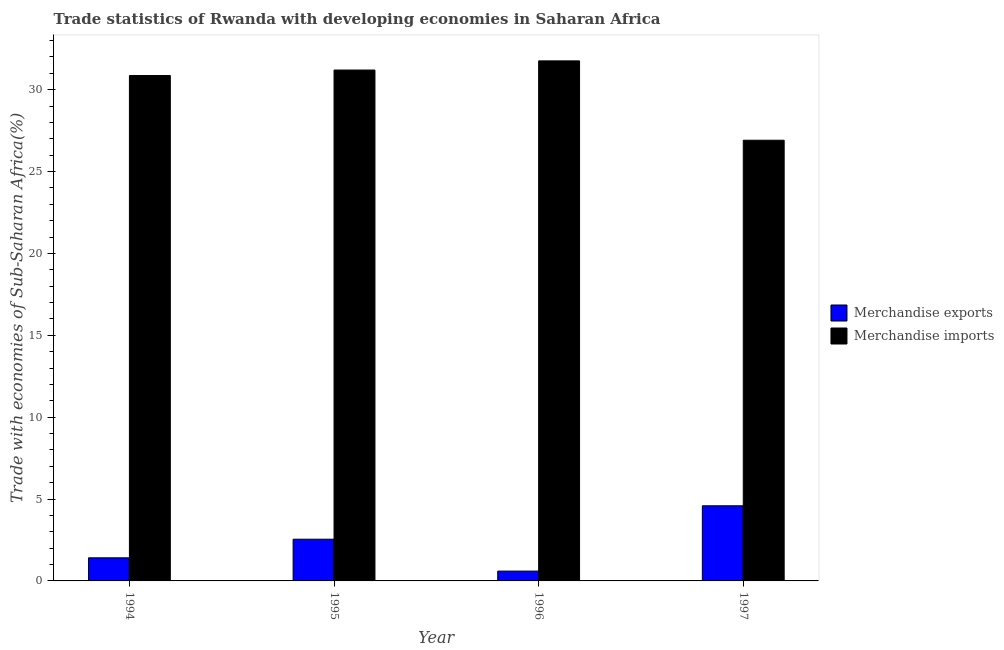How many bars are there on the 4th tick from the right?
Give a very brief answer. 2. What is the merchandise exports in 1997?
Your answer should be compact. 4.59. Across all years, what is the maximum merchandise imports?
Your response must be concise. 31.76. Across all years, what is the minimum merchandise imports?
Provide a succinct answer. 26.91. In which year was the merchandise exports maximum?
Offer a very short reply. 1997. In which year was the merchandise imports minimum?
Provide a short and direct response. 1997. What is the total merchandise exports in the graph?
Keep it short and to the point. 9.15. What is the difference between the merchandise imports in 1994 and that in 1995?
Offer a very short reply. -0.33. What is the difference between the merchandise imports in 1996 and the merchandise exports in 1997?
Keep it short and to the point. 4.85. What is the average merchandise exports per year?
Offer a terse response. 2.29. What is the ratio of the merchandise exports in 1994 to that in 1995?
Provide a short and direct response. 0.55. Is the difference between the merchandise imports in 1996 and 1997 greater than the difference between the merchandise exports in 1996 and 1997?
Make the answer very short. No. What is the difference between the highest and the second highest merchandise exports?
Your answer should be compact. 2.04. What is the difference between the highest and the lowest merchandise exports?
Offer a very short reply. 3.99. In how many years, is the merchandise exports greater than the average merchandise exports taken over all years?
Your response must be concise. 2. How many bars are there?
Keep it short and to the point. 8. Are all the bars in the graph horizontal?
Ensure brevity in your answer.  No. How many years are there in the graph?
Give a very brief answer. 4. What is the difference between two consecutive major ticks on the Y-axis?
Give a very brief answer. 5. Does the graph contain grids?
Provide a short and direct response. No. What is the title of the graph?
Provide a succinct answer. Trade statistics of Rwanda with developing economies in Saharan Africa. Does "Banks" appear as one of the legend labels in the graph?
Give a very brief answer. No. What is the label or title of the Y-axis?
Offer a very short reply. Trade with economies of Sub-Saharan Africa(%). What is the Trade with economies of Sub-Saharan Africa(%) in Merchandise exports in 1994?
Your answer should be very brief. 1.41. What is the Trade with economies of Sub-Saharan Africa(%) of Merchandise imports in 1994?
Ensure brevity in your answer.  30.86. What is the Trade with economies of Sub-Saharan Africa(%) in Merchandise exports in 1995?
Your answer should be compact. 2.55. What is the Trade with economies of Sub-Saharan Africa(%) in Merchandise imports in 1995?
Provide a succinct answer. 31.2. What is the Trade with economies of Sub-Saharan Africa(%) in Merchandise exports in 1996?
Keep it short and to the point. 0.6. What is the Trade with economies of Sub-Saharan Africa(%) of Merchandise imports in 1996?
Your response must be concise. 31.76. What is the Trade with economies of Sub-Saharan Africa(%) in Merchandise exports in 1997?
Your response must be concise. 4.59. What is the Trade with economies of Sub-Saharan Africa(%) in Merchandise imports in 1997?
Your answer should be very brief. 26.91. Across all years, what is the maximum Trade with economies of Sub-Saharan Africa(%) of Merchandise exports?
Ensure brevity in your answer.  4.59. Across all years, what is the maximum Trade with economies of Sub-Saharan Africa(%) in Merchandise imports?
Your response must be concise. 31.76. Across all years, what is the minimum Trade with economies of Sub-Saharan Africa(%) in Merchandise exports?
Your answer should be compact. 0.6. Across all years, what is the minimum Trade with economies of Sub-Saharan Africa(%) of Merchandise imports?
Ensure brevity in your answer.  26.91. What is the total Trade with economies of Sub-Saharan Africa(%) of Merchandise exports in the graph?
Make the answer very short. 9.15. What is the total Trade with economies of Sub-Saharan Africa(%) of Merchandise imports in the graph?
Provide a succinct answer. 120.73. What is the difference between the Trade with economies of Sub-Saharan Africa(%) of Merchandise exports in 1994 and that in 1995?
Give a very brief answer. -1.14. What is the difference between the Trade with economies of Sub-Saharan Africa(%) in Merchandise imports in 1994 and that in 1995?
Provide a short and direct response. -0.34. What is the difference between the Trade with economies of Sub-Saharan Africa(%) in Merchandise exports in 1994 and that in 1996?
Offer a very short reply. 0.81. What is the difference between the Trade with economies of Sub-Saharan Africa(%) in Merchandise imports in 1994 and that in 1996?
Keep it short and to the point. -0.89. What is the difference between the Trade with economies of Sub-Saharan Africa(%) in Merchandise exports in 1994 and that in 1997?
Give a very brief answer. -3.18. What is the difference between the Trade with economies of Sub-Saharan Africa(%) of Merchandise imports in 1994 and that in 1997?
Offer a very short reply. 3.95. What is the difference between the Trade with economies of Sub-Saharan Africa(%) in Merchandise exports in 1995 and that in 1996?
Your answer should be very brief. 1.95. What is the difference between the Trade with economies of Sub-Saharan Africa(%) of Merchandise imports in 1995 and that in 1996?
Offer a terse response. -0.56. What is the difference between the Trade with economies of Sub-Saharan Africa(%) in Merchandise exports in 1995 and that in 1997?
Offer a very short reply. -2.04. What is the difference between the Trade with economies of Sub-Saharan Africa(%) of Merchandise imports in 1995 and that in 1997?
Your answer should be very brief. 4.29. What is the difference between the Trade with economies of Sub-Saharan Africa(%) of Merchandise exports in 1996 and that in 1997?
Your answer should be compact. -3.99. What is the difference between the Trade with economies of Sub-Saharan Africa(%) in Merchandise imports in 1996 and that in 1997?
Keep it short and to the point. 4.85. What is the difference between the Trade with economies of Sub-Saharan Africa(%) of Merchandise exports in 1994 and the Trade with economies of Sub-Saharan Africa(%) of Merchandise imports in 1995?
Your answer should be compact. -29.79. What is the difference between the Trade with economies of Sub-Saharan Africa(%) in Merchandise exports in 1994 and the Trade with economies of Sub-Saharan Africa(%) in Merchandise imports in 1996?
Keep it short and to the point. -30.35. What is the difference between the Trade with economies of Sub-Saharan Africa(%) of Merchandise exports in 1994 and the Trade with economies of Sub-Saharan Africa(%) of Merchandise imports in 1997?
Provide a succinct answer. -25.5. What is the difference between the Trade with economies of Sub-Saharan Africa(%) of Merchandise exports in 1995 and the Trade with economies of Sub-Saharan Africa(%) of Merchandise imports in 1996?
Your answer should be very brief. -29.21. What is the difference between the Trade with economies of Sub-Saharan Africa(%) of Merchandise exports in 1995 and the Trade with economies of Sub-Saharan Africa(%) of Merchandise imports in 1997?
Ensure brevity in your answer.  -24.36. What is the difference between the Trade with economies of Sub-Saharan Africa(%) in Merchandise exports in 1996 and the Trade with economies of Sub-Saharan Africa(%) in Merchandise imports in 1997?
Ensure brevity in your answer.  -26.31. What is the average Trade with economies of Sub-Saharan Africa(%) of Merchandise exports per year?
Give a very brief answer. 2.29. What is the average Trade with economies of Sub-Saharan Africa(%) of Merchandise imports per year?
Provide a short and direct response. 30.18. In the year 1994, what is the difference between the Trade with economies of Sub-Saharan Africa(%) of Merchandise exports and Trade with economies of Sub-Saharan Africa(%) of Merchandise imports?
Give a very brief answer. -29.45. In the year 1995, what is the difference between the Trade with economies of Sub-Saharan Africa(%) of Merchandise exports and Trade with economies of Sub-Saharan Africa(%) of Merchandise imports?
Your answer should be compact. -28.65. In the year 1996, what is the difference between the Trade with economies of Sub-Saharan Africa(%) in Merchandise exports and Trade with economies of Sub-Saharan Africa(%) in Merchandise imports?
Offer a very short reply. -31.16. In the year 1997, what is the difference between the Trade with economies of Sub-Saharan Africa(%) of Merchandise exports and Trade with economies of Sub-Saharan Africa(%) of Merchandise imports?
Ensure brevity in your answer.  -22.32. What is the ratio of the Trade with economies of Sub-Saharan Africa(%) of Merchandise exports in 1994 to that in 1995?
Provide a succinct answer. 0.55. What is the ratio of the Trade with economies of Sub-Saharan Africa(%) of Merchandise imports in 1994 to that in 1995?
Provide a short and direct response. 0.99. What is the ratio of the Trade with economies of Sub-Saharan Africa(%) of Merchandise exports in 1994 to that in 1996?
Ensure brevity in your answer.  2.35. What is the ratio of the Trade with economies of Sub-Saharan Africa(%) of Merchandise imports in 1994 to that in 1996?
Your answer should be compact. 0.97. What is the ratio of the Trade with economies of Sub-Saharan Africa(%) in Merchandise exports in 1994 to that in 1997?
Provide a short and direct response. 0.31. What is the ratio of the Trade with economies of Sub-Saharan Africa(%) of Merchandise imports in 1994 to that in 1997?
Your answer should be very brief. 1.15. What is the ratio of the Trade with economies of Sub-Saharan Africa(%) of Merchandise exports in 1995 to that in 1996?
Keep it short and to the point. 4.24. What is the ratio of the Trade with economies of Sub-Saharan Africa(%) in Merchandise imports in 1995 to that in 1996?
Provide a short and direct response. 0.98. What is the ratio of the Trade with economies of Sub-Saharan Africa(%) of Merchandise exports in 1995 to that in 1997?
Make the answer very short. 0.56. What is the ratio of the Trade with economies of Sub-Saharan Africa(%) of Merchandise imports in 1995 to that in 1997?
Keep it short and to the point. 1.16. What is the ratio of the Trade with economies of Sub-Saharan Africa(%) in Merchandise exports in 1996 to that in 1997?
Offer a terse response. 0.13. What is the ratio of the Trade with economies of Sub-Saharan Africa(%) in Merchandise imports in 1996 to that in 1997?
Ensure brevity in your answer.  1.18. What is the difference between the highest and the second highest Trade with economies of Sub-Saharan Africa(%) of Merchandise exports?
Offer a very short reply. 2.04. What is the difference between the highest and the second highest Trade with economies of Sub-Saharan Africa(%) of Merchandise imports?
Your response must be concise. 0.56. What is the difference between the highest and the lowest Trade with economies of Sub-Saharan Africa(%) of Merchandise exports?
Your answer should be compact. 3.99. What is the difference between the highest and the lowest Trade with economies of Sub-Saharan Africa(%) of Merchandise imports?
Keep it short and to the point. 4.85. 